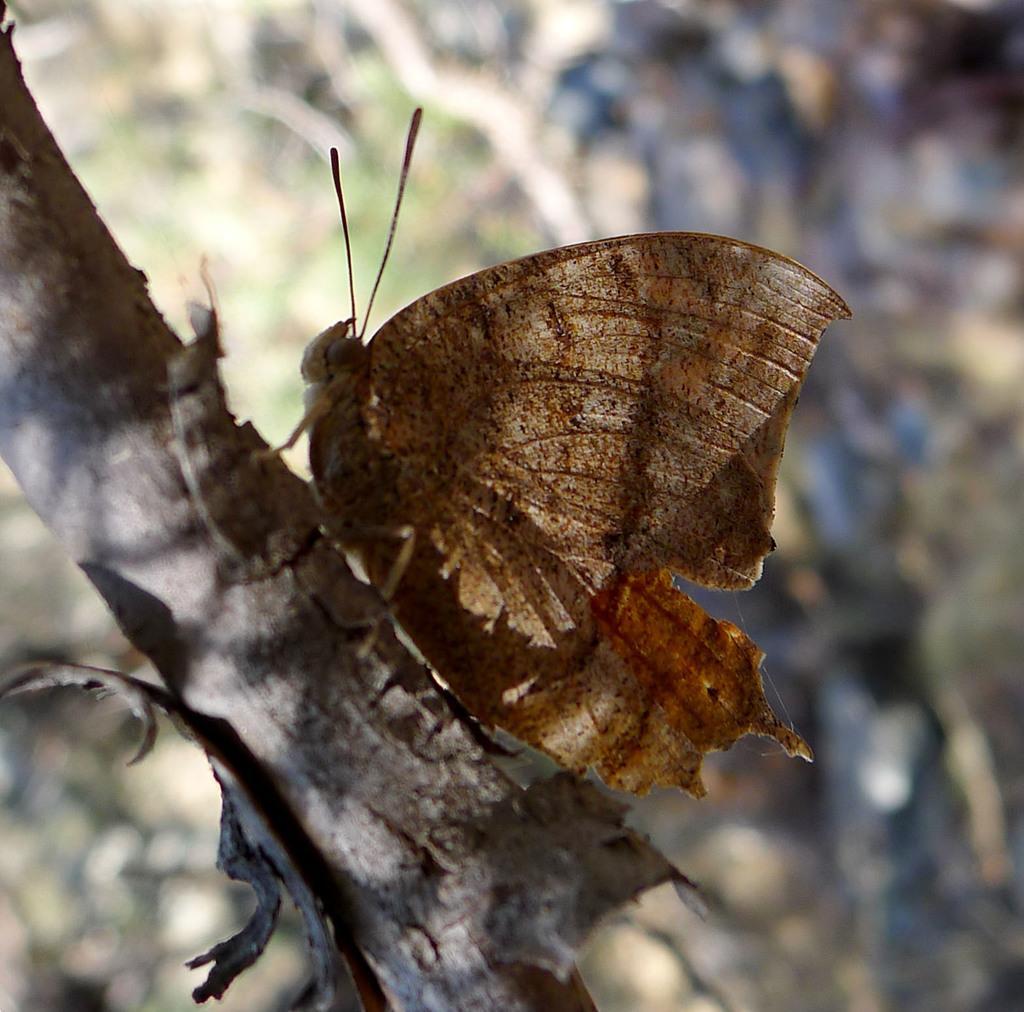Can you describe this image briefly? In this image we can see butterfly on the branch of the tree. 